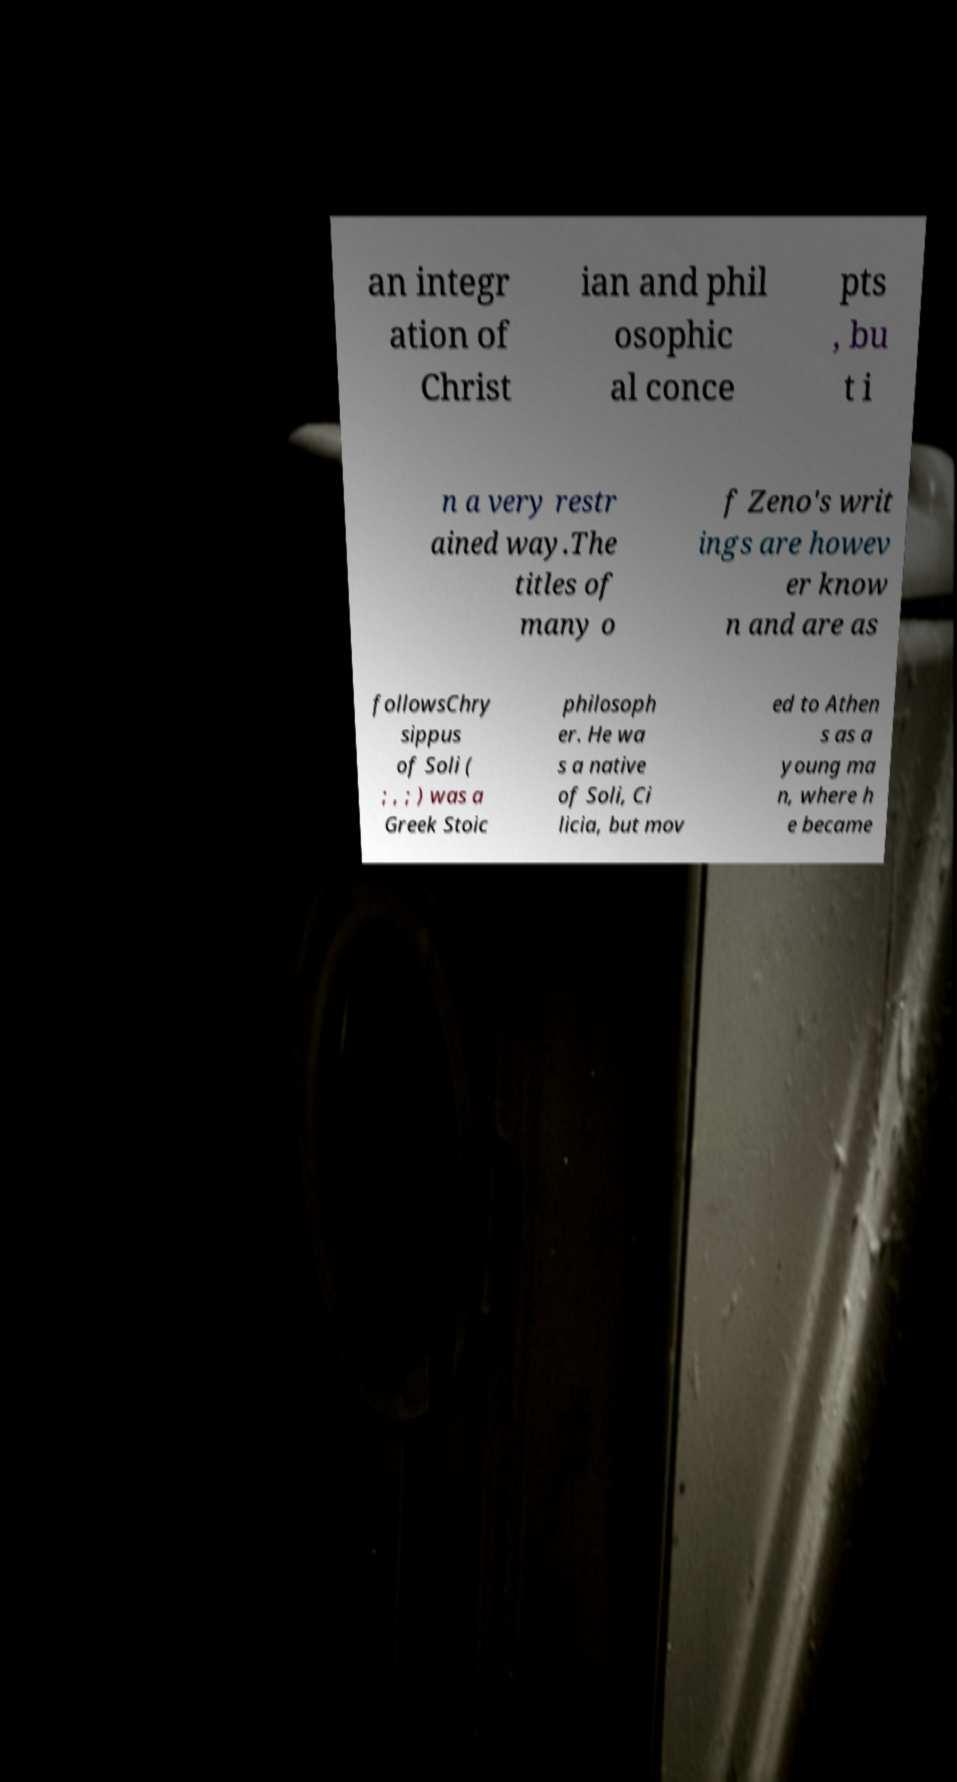For documentation purposes, I need the text within this image transcribed. Could you provide that? an integr ation of Christ ian and phil osophic al conce pts , bu t i n a very restr ained way.The titles of many o f Zeno's writ ings are howev er know n and are as followsChry sippus of Soli ( ; , ; ) was a Greek Stoic philosoph er. He wa s a native of Soli, Ci licia, but mov ed to Athen s as a young ma n, where h e became 